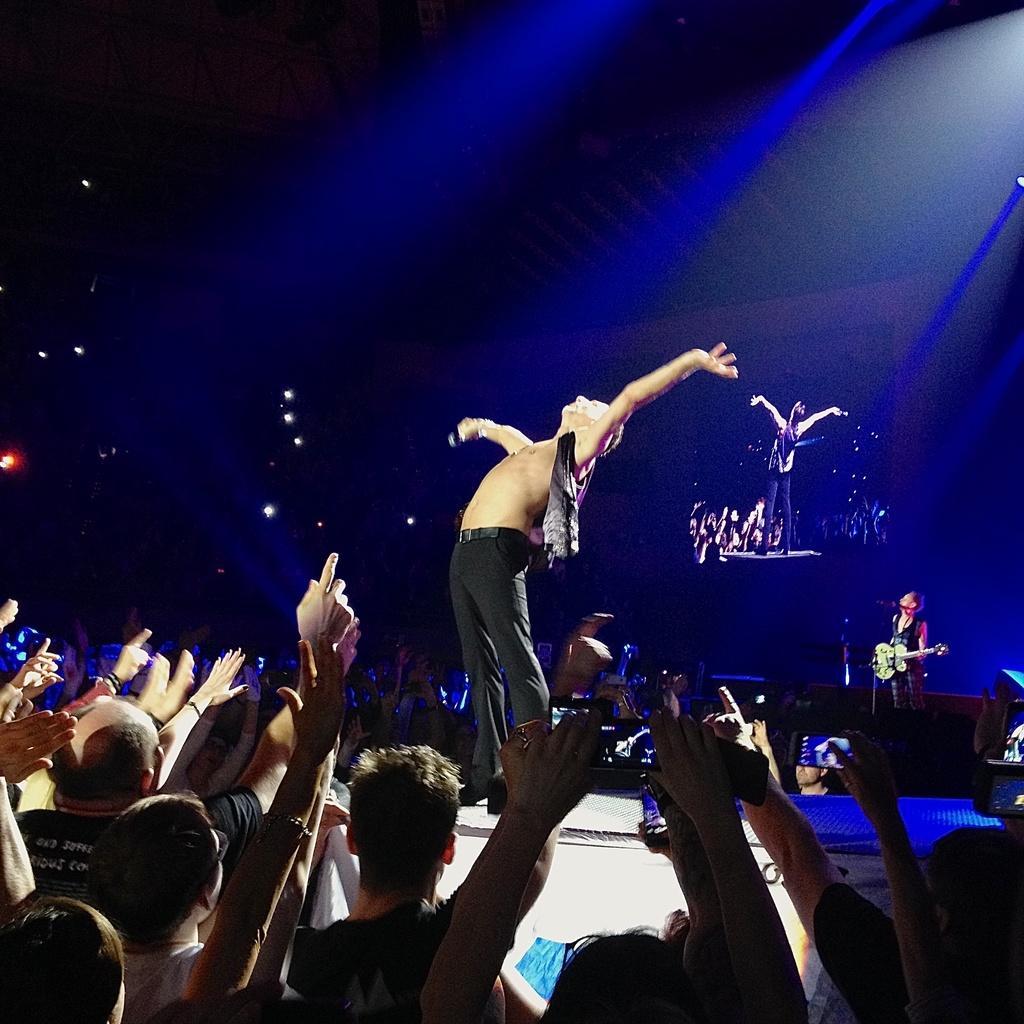Describe this image in one or two sentences. A man is standing on the stage he is holding a mic. There are people around the stage. Some are taking pictures. In the right a man is playing guitar in front of him there is a mic. In the background there is a screen. 